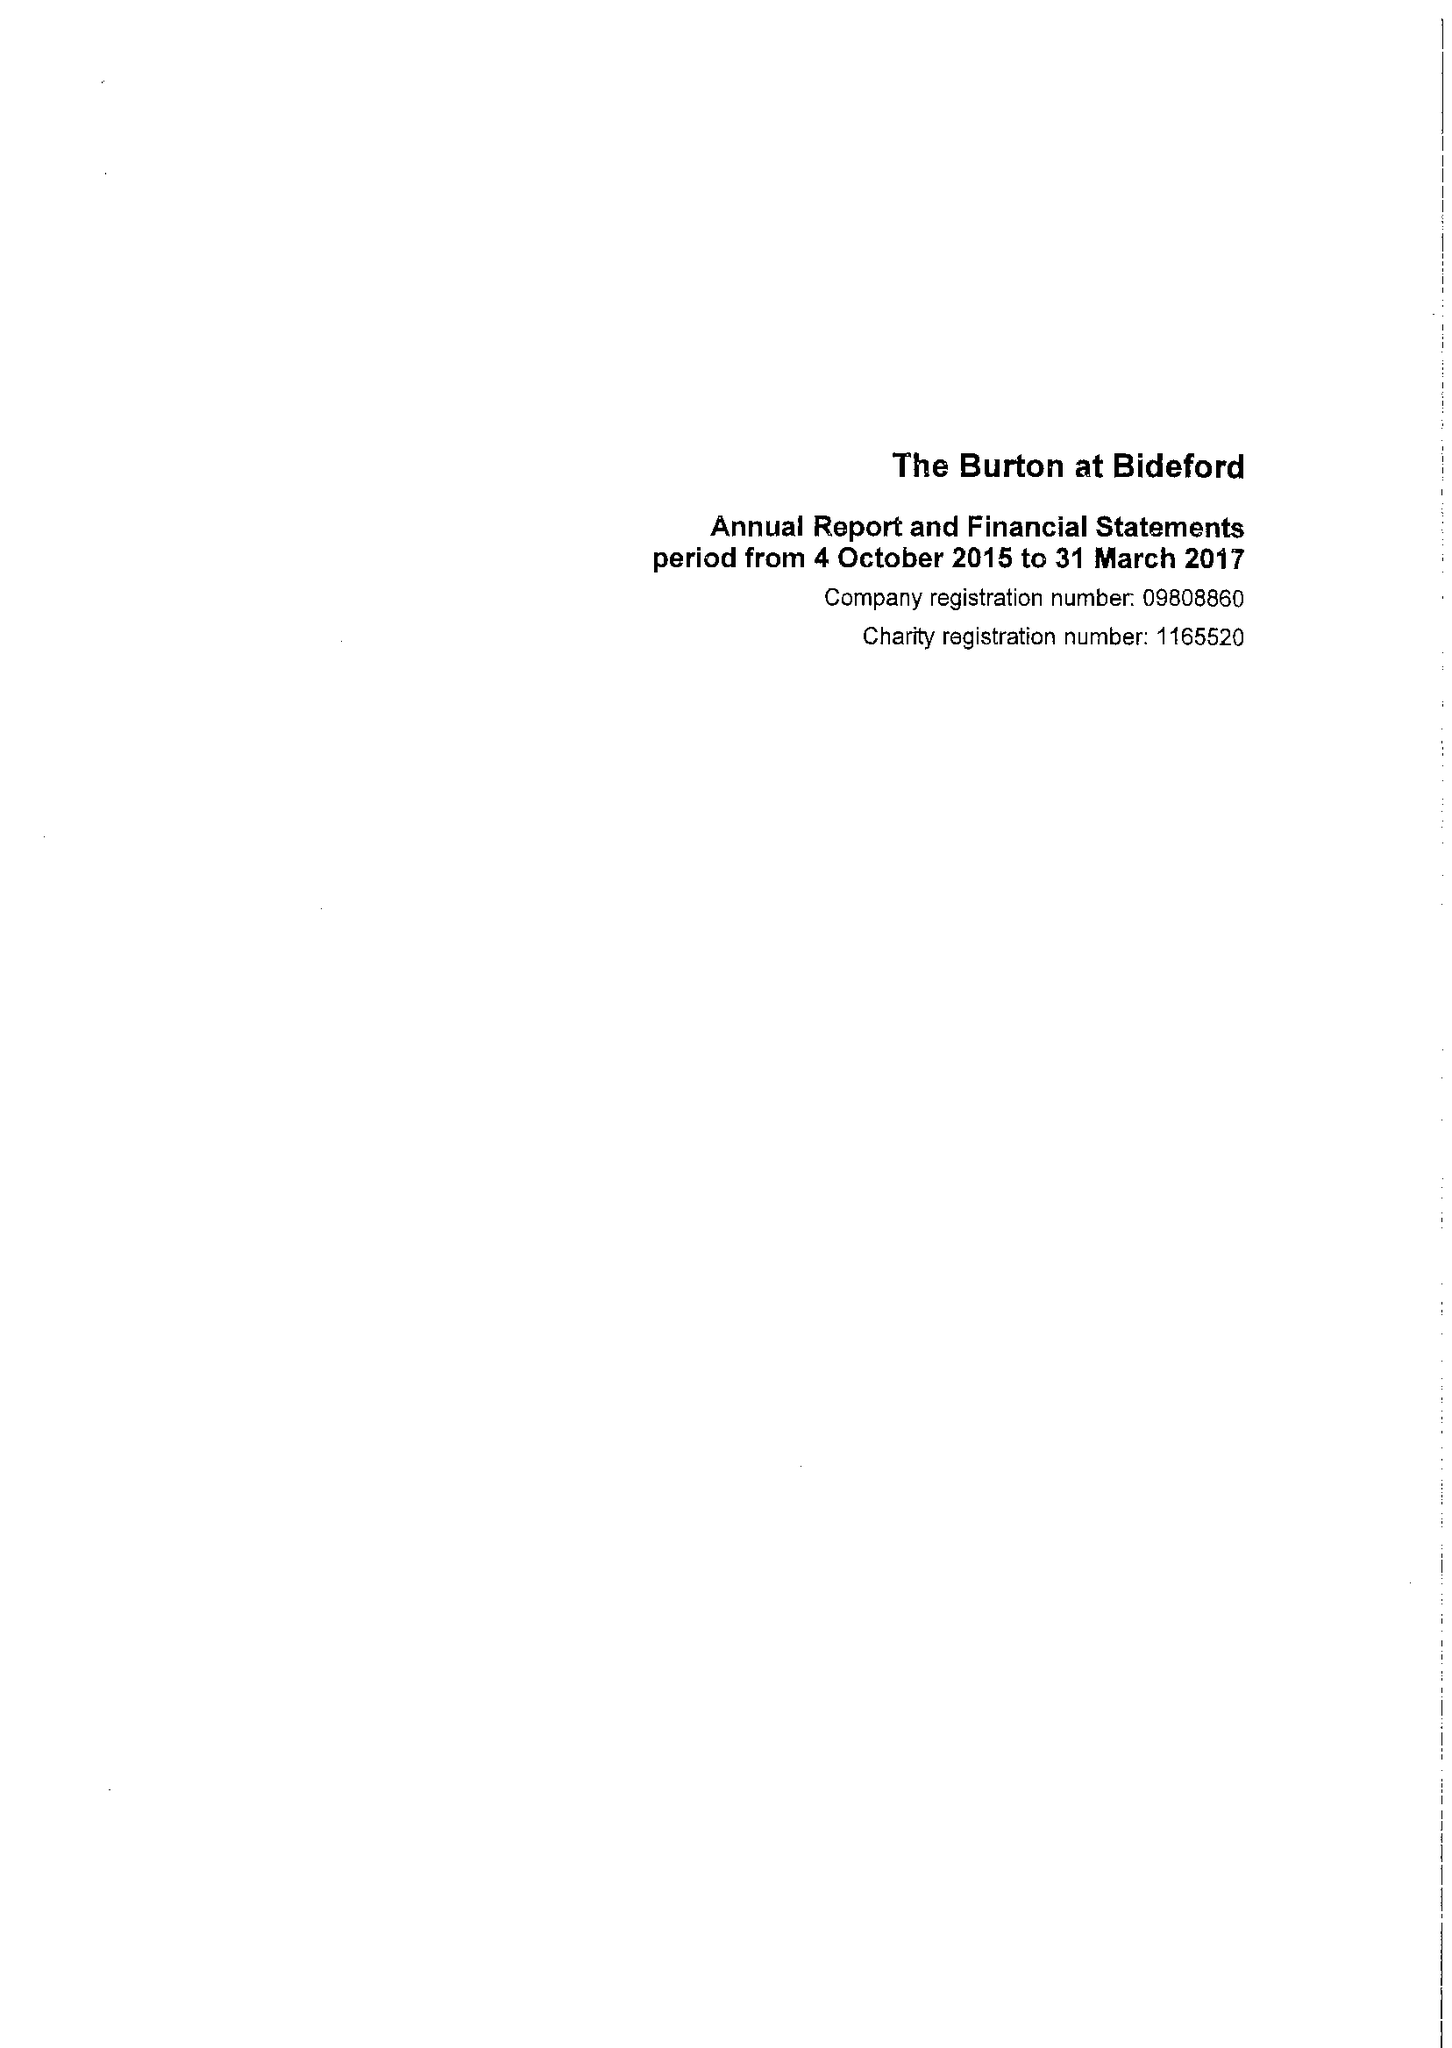What is the value for the spending_annually_in_british_pounds?
Answer the question using a single word or phrase. 279768.00 